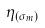<formula> <loc_0><loc_0><loc_500><loc_500>\eta _ { ( \sigma _ { m } ) }</formula> 